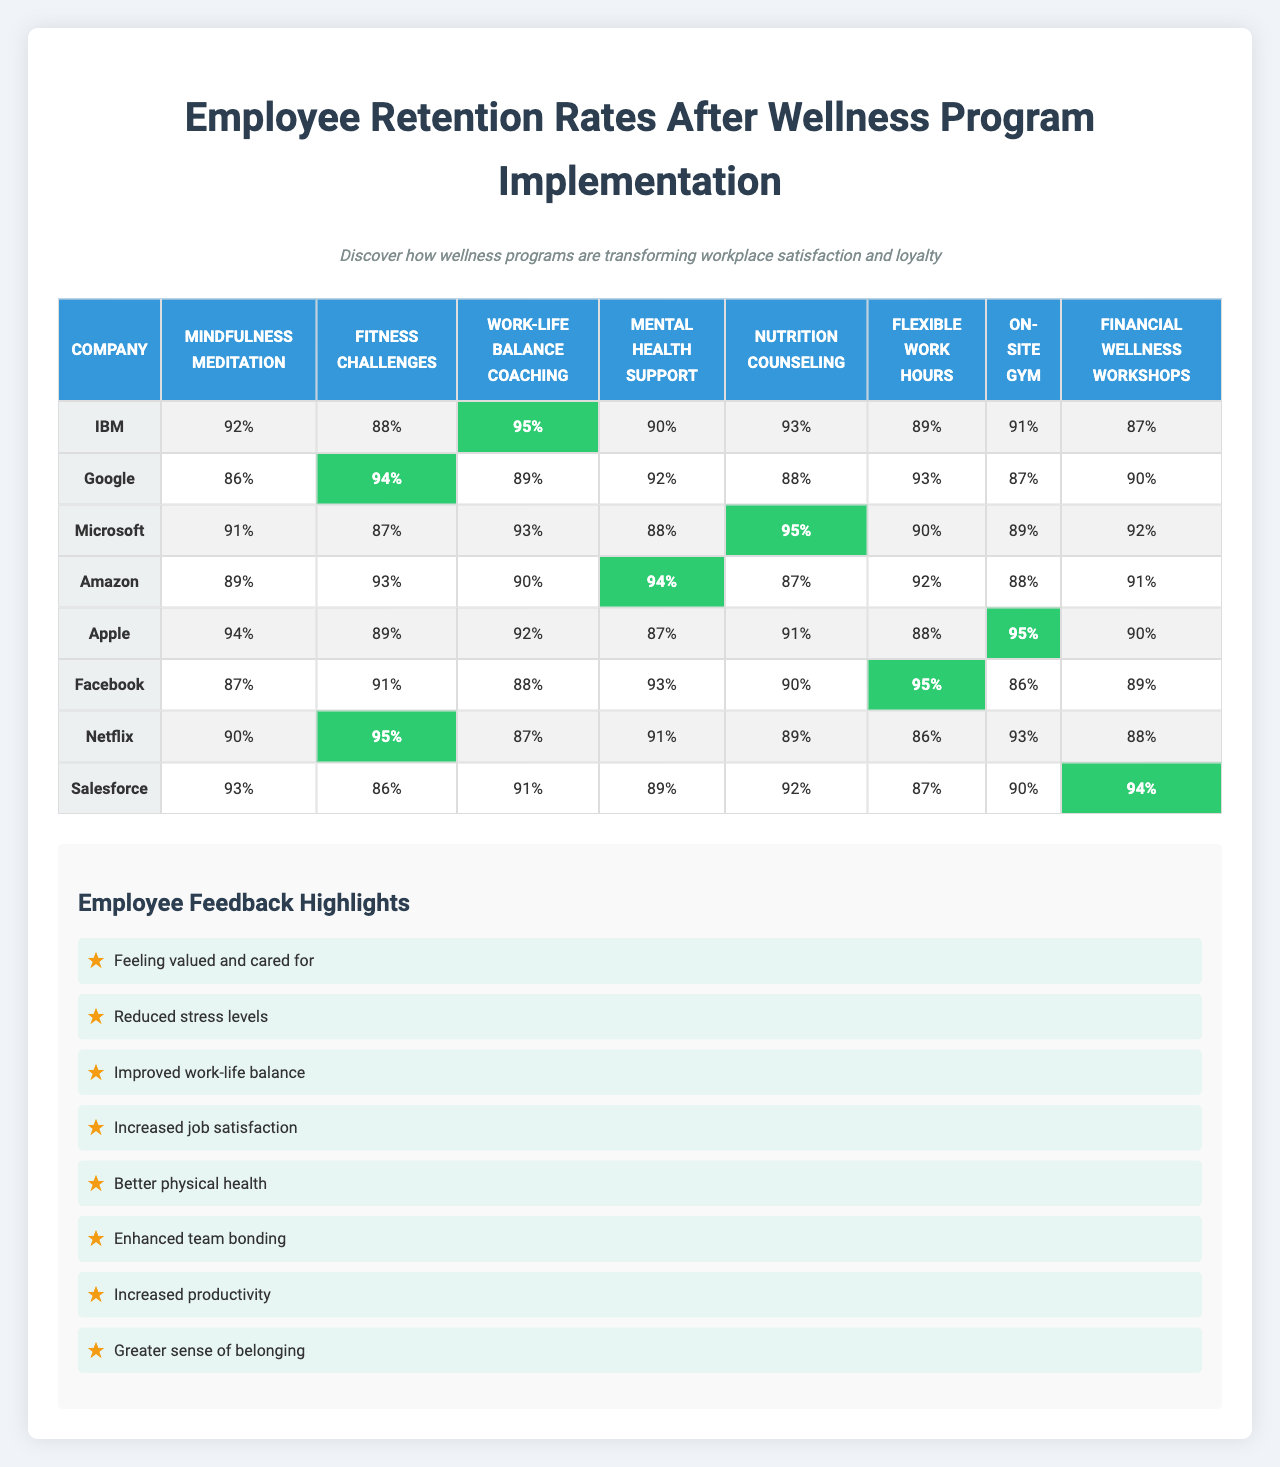What company had the highest retention rate for mental health support? The retention rate for mental health support is as follows: IBM (90%), Google (92%), Microsoft (88%), Amazon (94%), Apple (87%), Facebook (93%), Netflix (91%), Salesforce (89%). The highest rate is 94% from Amazon.
Answer: Amazon What was the lowest retention rate for any wellness program among the companies? Looking through the table, the lowest retention rate observed is 86%, which belongs to Facebook for the fitness challenges program.
Answer: 86% Which wellness program had the highest overall retention rate across all companies? To determine this, I examine each column for the highest value. The retention rates for each program reveal that "Financial wellness workshops" had the highest value at 95% from Netflix.
Answer: 95% What is the average retention rate for Google across all wellness programs? For Google, the retention rates are 86%, 94%, 89%, 92%, 88%, 93%, 87%, and 90%. The sum of these rates is 719. Dividing this by the number of programs (8) gives an average of 89.875, which is approximately 90 when rounded.
Answer: 90 Did any company show a consistent increase in retention rates across all wellness programs? By examining the data for each company, none consistently increase. For example, IBM shows a retention rate decrease in the 5th and 6th programs (93% to 89%). Therefore, the answer is no.
Answer: No What is the total retention rate for Amazon and Apple combined for the flexible work hours program? The retention rates for Amazon and Apple for flexible work hours are 92% and 88% respectively. Adding these together gives 92 + 88 = 180.
Answer: 180 Which employee feedback was most frequently associated with high retention rates? The feedbacks are independent of the retention rates mentioned and are about employees feeling valued and cared for. This aligns closely with the high rates seen generally, but direct correlation cannot be firmly established from the data provided. The feedback is likely significant but not quantifiable directly.
Answer: Feedback doesn't directly correlate Which company had the second-highest retention rate for fitness challenges? The retention rates for fitness challenges are IBM (88%), Google (94%), Microsoft (87%), Amazon (93%), Apple (89%), Facebook (86%), Netflix (95%), and Salesforce (90%). The second-highest rate is 93% from Amazon.
Answer: Amazon What is the difference between the highest and lowest retention rates for on-site gym across all companies? The retention rates for on-site gym are as follows: IBM (89%), Google (87%), Microsoft (90%), Amazon (92%), Apple (95%), Facebook (86%), Netflix (93%), Salesforce (88%). The highest rate is 95% (Apple) and the lowest is 86% (Facebook). The difference between them is 95 - 86 = 9.
Answer: 9 For which wellness program did Microsoft experience the highest retention rate? Checking Microsoft's rates: 91% for mindfulness meditation, 87% for fitness challenges, 93% for work-life balance coaching, 88% for mental health support, 95% for nutrition counseling, 90% for flexible work hours, 89% for on-site gym, and 92% for financial wellness workshops. The highest is 95% for nutrition counseling.
Answer: Nutrition counseling 